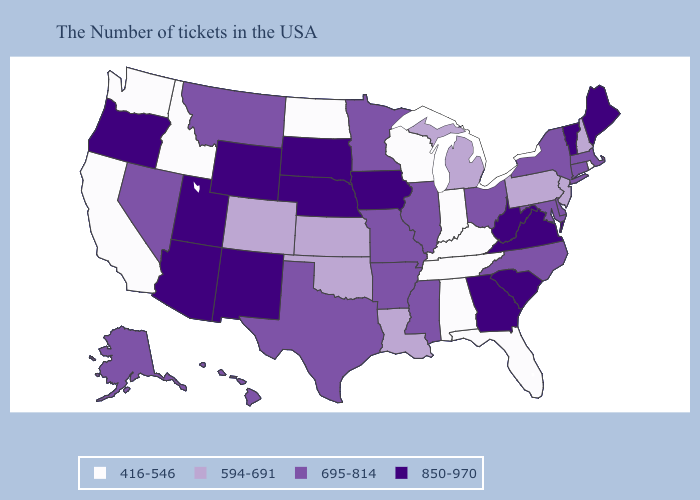What is the highest value in the USA?
Concise answer only. 850-970. Name the states that have a value in the range 850-970?
Quick response, please. Maine, Vermont, Virginia, South Carolina, West Virginia, Georgia, Iowa, Nebraska, South Dakota, Wyoming, New Mexico, Utah, Arizona, Oregon. Name the states that have a value in the range 594-691?
Give a very brief answer. New Hampshire, New Jersey, Pennsylvania, Michigan, Louisiana, Kansas, Oklahoma, Colorado. Among the states that border Arizona , which have the highest value?
Answer briefly. New Mexico, Utah. Does South Dakota have the same value as Idaho?
Short answer required. No. What is the value of West Virginia?
Short answer required. 850-970. What is the lowest value in the Northeast?
Write a very short answer. 416-546. Which states hav the highest value in the MidWest?
Give a very brief answer. Iowa, Nebraska, South Dakota. Does the first symbol in the legend represent the smallest category?
Give a very brief answer. Yes. Among the states that border Vermont , does New Hampshire have the highest value?
Answer briefly. No. Name the states that have a value in the range 695-814?
Be succinct. Massachusetts, Connecticut, New York, Delaware, Maryland, North Carolina, Ohio, Illinois, Mississippi, Missouri, Arkansas, Minnesota, Texas, Montana, Nevada, Alaska, Hawaii. Does the first symbol in the legend represent the smallest category?
Give a very brief answer. Yes. What is the lowest value in the USA?
Write a very short answer. 416-546. What is the lowest value in states that border Florida?
Short answer required. 416-546. Does the map have missing data?
Give a very brief answer. No. 